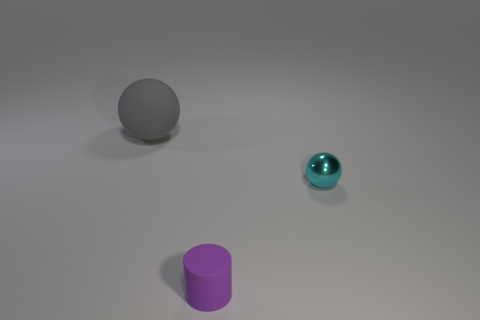Is there any other thing that is the same size as the gray object?
Provide a succinct answer. No. The purple matte object that is the same size as the metal object is what shape?
Your response must be concise. Cylinder. Is there another small object that has the same shape as the gray thing?
Keep it short and to the point. Yes. Does the tiny cyan object have the same material as the object that is left of the small matte cylinder?
Keep it short and to the point. No. How many other things are made of the same material as the tiny cylinder?
Offer a very short reply. 1. Are there more cyan balls that are behind the small purple rubber thing than large cyan cylinders?
Provide a succinct answer. Yes. What number of large gray rubber balls are behind the matte thing on the right side of the large gray sphere that is behind the cyan metal thing?
Your answer should be compact. 1. There is a matte object behind the purple matte cylinder; does it have the same shape as the tiny purple thing?
Provide a succinct answer. No. There is a thing behind the cyan ball; what is it made of?
Your answer should be compact. Rubber. There is a thing that is behind the purple thing and on the left side of the small metallic object; what is its shape?
Offer a very short reply. Sphere. 